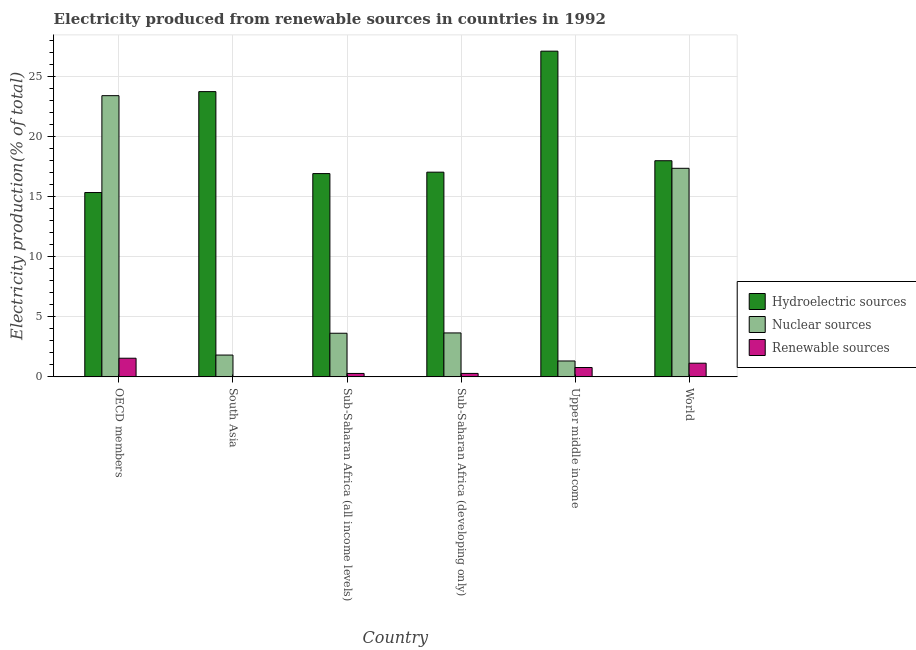How many groups of bars are there?
Your answer should be very brief. 6. How many bars are there on the 6th tick from the left?
Your answer should be very brief. 3. What is the percentage of electricity produced by renewable sources in Upper middle income?
Keep it short and to the point. 0.78. Across all countries, what is the maximum percentage of electricity produced by nuclear sources?
Provide a succinct answer. 23.41. Across all countries, what is the minimum percentage of electricity produced by nuclear sources?
Provide a succinct answer. 1.32. In which country was the percentage of electricity produced by renewable sources maximum?
Give a very brief answer. OECD members. In which country was the percentage of electricity produced by nuclear sources minimum?
Offer a very short reply. Upper middle income. What is the total percentage of electricity produced by hydroelectric sources in the graph?
Provide a short and direct response. 118.15. What is the difference between the percentage of electricity produced by renewable sources in OECD members and that in Sub-Saharan Africa (all income levels)?
Provide a short and direct response. 1.27. What is the difference between the percentage of electricity produced by hydroelectric sources in Sub-Saharan Africa (all income levels) and the percentage of electricity produced by renewable sources in World?
Provide a short and direct response. 15.78. What is the average percentage of electricity produced by renewable sources per country?
Ensure brevity in your answer.  0.68. What is the difference between the percentage of electricity produced by nuclear sources and percentage of electricity produced by hydroelectric sources in Sub-Saharan Africa (developing only)?
Provide a short and direct response. -13.38. In how many countries, is the percentage of electricity produced by hydroelectric sources greater than 23 %?
Your answer should be very brief. 2. What is the ratio of the percentage of electricity produced by renewable sources in South Asia to that in Sub-Saharan Africa (all income levels)?
Offer a very short reply. 0.08. What is the difference between the highest and the second highest percentage of electricity produced by renewable sources?
Offer a very short reply. 0.41. What is the difference between the highest and the lowest percentage of electricity produced by nuclear sources?
Provide a short and direct response. 22.08. In how many countries, is the percentage of electricity produced by renewable sources greater than the average percentage of electricity produced by renewable sources taken over all countries?
Provide a succinct answer. 3. What does the 1st bar from the left in OECD members represents?
Offer a very short reply. Hydroelectric sources. What does the 2nd bar from the right in South Asia represents?
Your answer should be compact. Nuclear sources. Is it the case that in every country, the sum of the percentage of electricity produced by hydroelectric sources and percentage of electricity produced by nuclear sources is greater than the percentage of electricity produced by renewable sources?
Your answer should be compact. Yes. Are all the bars in the graph horizontal?
Offer a terse response. No. What is the difference between two consecutive major ticks on the Y-axis?
Offer a very short reply. 5. Are the values on the major ticks of Y-axis written in scientific E-notation?
Keep it short and to the point. No. Does the graph contain grids?
Give a very brief answer. Yes. What is the title of the graph?
Your answer should be compact. Electricity produced from renewable sources in countries in 1992. What is the label or title of the X-axis?
Offer a very short reply. Country. What is the Electricity production(% of total) in Hydroelectric sources in OECD members?
Keep it short and to the point. 15.34. What is the Electricity production(% of total) of Nuclear sources in OECD members?
Provide a succinct answer. 23.41. What is the Electricity production(% of total) in Renewable sources in OECD members?
Offer a very short reply. 1.55. What is the Electricity production(% of total) in Hydroelectric sources in South Asia?
Give a very brief answer. 23.74. What is the Electricity production(% of total) of Nuclear sources in South Asia?
Offer a very short reply. 1.82. What is the Electricity production(% of total) in Renewable sources in South Asia?
Keep it short and to the point. 0.02. What is the Electricity production(% of total) in Hydroelectric sources in Sub-Saharan Africa (all income levels)?
Give a very brief answer. 16.92. What is the Electricity production(% of total) in Nuclear sources in Sub-Saharan Africa (all income levels)?
Provide a succinct answer. 3.63. What is the Electricity production(% of total) in Renewable sources in Sub-Saharan Africa (all income levels)?
Ensure brevity in your answer.  0.29. What is the Electricity production(% of total) of Hydroelectric sources in Sub-Saharan Africa (developing only)?
Your answer should be compact. 17.04. What is the Electricity production(% of total) in Nuclear sources in Sub-Saharan Africa (developing only)?
Keep it short and to the point. 3.66. What is the Electricity production(% of total) in Renewable sources in Sub-Saharan Africa (developing only)?
Provide a short and direct response. 0.29. What is the Electricity production(% of total) of Hydroelectric sources in Upper middle income?
Keep it short and to the point. 27.11. What is the Electricity production(% of total) of Nuclear sources in Upper middle income?
Your answer should be compact. 1.32. What is the Electricity production(% of total) of Renewable sources in Upper middle income?
Offer a very short reply. 0.78. What is the Electricity production(% of total) of Hydroelectric sources in World?
Give a very brief answer. 17.99. What is the Electricity production(% of total) of Nuclear sources in World?
Keep it short and to the point. 17.36. What is the Electricity production(% of total) in Renewable sources in World?
Your answer should be very brief. 1.14. Across all countries, what is the maximum Electricity production(% of total) of Hydroelectric sources?
Your answer should be compact. 27.11. Across all countries, what is the maximum Electricity production(% of total) in Nuclear sources?
Your answer should be compact. 23.41. Across all countries, what is the maximum Electricity production(% of total) in Renewable sources?
Offer a very short reply. 1.55. Across all countries, what is the minimum Electricity production(% of total) in Hydroelectric sources?
Offer a very short reply. 15.34. Across all countries, what is the minimum Electricity production(% of total) in Nuclear sources?
Make the answer very short. 1.32. Across all countries, what is the minimum Electricity production(% of total) of Renewable sources?
Offer a terse response. 0.02. What is the total Electricity production(% of total) of Hydroelectric sources in the graph?
Ensure brevity in your answer.  118.15. What is the total Electricity production(% of total) in Nuclear sources in the graph?
Make the answer very short. 51.19. What is the total Electricity production(% of total) in Renewable sources in the graph?
Give a very brief answer. 4.06. What is the difference between the Electricity production(% of total) in Hydroelectric sources in OECD members and that in South Asia?
Your answer should be compact. -8.4. What is the difference between the Electricity production(% of total) of Nuclear sources in OECD members and that in South Asia?
Offer a very short reply. 21.59. What is the difference between the Electricity production(% of total) of Renewable sources in OECD members and that in South Asia?
Keep it short and to the point. 1.53. What is the difference between the Electricity production(% of total) in Hydroelectric sources in OECD members and that in Sub-Saharan Africa (all income levels)?
Your answer should be very brief. -1.58. What is the difference between the Electricity production(% of total) in Nuclear sources in OECD members and that in Sub-Saharan Africa (all income levels)?
Your response must be concise. 19.77. What is the difference between the Electricity production(% of total) in Renewable sources in OECD members and that in Sub-Saharan Africa (all income levels)?
Provide a succinct answer. 1.27. What is the difference between the Electricity production(% of total) of Hydroelectric sources in OECD members and that in Sub-Saharan Africa (developing only)?
Offer a very short reply. -1.7. What is the difference between the Electricity production(% of total) in Nuclear sources in OECD members and that in Sub-Saharan Africa (developing only)?
Make the answer very short. 19.75. What is the difference between the Electricity production(% of total) of Renewable sources in OECD members and that in Sub-Saharan Africa (developing only)?
Make the answer very short. 1.26. What is the difference between the Electricity production(% of total) of Hydroelectric sources in OECD members and that in Upper middle income?
Your answer should be compact. -11.77. What is the difference between the Electricity production(% of total) of Nuclear sources in OECD members and that in Upper middle income?
Your answer should be very brief. 22.08. What is the difference between the Electricity production(% of total) of Renewable sources in OECD members and that in Upper middle income?
Your response must be concise. 0.77. What is the difference between the Electricity production(% of total) of Hydroelectric sources in OECD members and that in World?
Make the answer very short. -2.65. What is the difference between the Electricity production(% of total) in Nuclear sources in OECD members and that in World?
Offer a terse response. 6.05. What is the difference between the Electricity production(% of total) in Renewable sources in OECD members and that in World?
Keep it short and to the point. 0.41. What is the difference between the Electricity production(% of total) in Hydroelectric sources in South Asia and that in Sub-Saharan Africa (all income levels)?
Keep it short and to the point. 6.82. What is the difference between the Electricity production(% of total) of Nuclear sources in South Asia and that in Sub-Saharan Africa (all income levels)?
Provide a succinct answer. -1.82. What is the difference between the Electricity production(% of total) of Renewable sources in South Asia and that in Sub-Saharan Africa (all income levels)?
Your response must be concise. -0.26. What is the difference between the Electricity production(% of total) of Hydroelectric sources in South Asia and that in Sub-Saharan Africa (developing only)?
Your answer should be very brief. 6.7. What is the difference between the Electricity production(% of total) in Nuclear sources in South Asia and that in Sub-Saharan Africa (developing only)?
Your answer should be very brief. -1.84. What is the difference between the Electricity production(% of total) of Renewable sources in South Asia and that in Sub-Saharan Africa (developing only)?
Keep it short and to the point. -0.27. What is the difference between the Electricity production(% of total) of Hydroelectric sources in South Asia and that in Upper middle income?
Offer a very short reply. -3.37. What is the difference between the Electricity production(% of total) in Nuclear sources in South Asia and that in Upper middle income?
Offer a very short reply. 0.49. What is the difference between the Electricity production(% of total) of Renewable sources in South Asia and that in Upper middle income?
Offer a terse response. -0.76. What is the difference between the Electricity production(% of total) of Hydroelectric sources in South Asia and that in World?
Keep it short and to the point. 5.75. What is the difference between the Electricity production(% of total) of Nuclear sources in South Asia and that in World?
Offer a terse response. -15.54. What is the difference between the Electricity production(% of total) in Renewable sources in South Asia and that in World?
Your answer should be compact. -1.12. What is the difference between the Electricity production(% of total) in Hydroelectric sources in Sub-Saharan Africa (all income levels) and that in Sub-Saharan Africa (developing only)?
Keep it short and to the point. -0.12. What is the difference between the Electricity production(% of total) in Nuclear sources in Sub-Saharan Africa (all income levels) and that in Sub-Saharan Africa (developing only)?
Your response must be concise. -0.03. What is the difference between the Electricity production(% of total) of Renewable sources in Sub-Saharan Africa (all income levels) and that in Sub-Saharan Africa (developing only)?
Provide a succinct answer. -0. What is the difference between the Electricity production(% of total) of Hydroelectric sources in Sub-Saharan Africa (all income levels) and that in Upper middle income?
Keep it short and to the point. -10.19. What is the difference between the Electricity production(% of total) of Nuclear sources in Sub-Saharan Africa (all income levels) and that in Upper middle income?
Keep it short and to the point. 2.31. What is the difference between the Electricity production(% of total) of Renewable sources in Sub-Saharan Africa (all income levels) and that in Upper middle income?
Give a very brief answer. -0.49. What is the difference between the Electricity production(% of total) of Hydroelectric sources in Sub-Saharan Africa (all income levels) and that in World?
Provide a short and direct response. -1.07. What is the difference between the Electricity production(% of total) of Nuclear sources in Sub-Saharan Africa (all income levels) and that in World?
Offer a terse response. -13.73. What is the difference between the Electricity production(% of total) in Renewable sources in Sub-Saharan Africa (all income levels) and that in World?
Provide a succinct answer. -0.85. What is the difference between the Electricity production(% of total) of Hydroelectric sources in Sub-Saharan Africa (developing only) and that in Upper middle income?
Keep it short and to the point. -10.07. What is the difference between the Electricity production(% of total) of Nuclear sources in Sub-Saharan Africa (developing only) and that in Upper middle income?
Offer a very short reply. 2.33. What is the difference between the Electricity production(% of total) in Renewable sources in Sub-Saharan Africa (developing only) and that in Upper middle income?
Ensure brevity in your answer.  -0.49. What is the difference between the Electricity production(% of total) of Hydroelectric sources in Sub-Saharan Africa (developing only) and that in World?
Offer a terse response. -0.95. What is the difference between the Electricity production(% of total) in Nuclear sources in Sub-Saharan Africa (developing only) and that in World?
Provide a short and direct response. -13.7. What is the difference between the Electricity production(% of total) in Renewable sources in Sub-Saharan Africa (developing only) and that in World?
Your response must be concise. -0.85. What is the difference between the Electricity production(% of total) in Hydroelectric sources in Upper middle income and that in World?
Your answer should be very brief. 9.12. What is the difference between the Electricity production(% of total) of Nuclear sources in Upper middle income and that in World?
Provide a succinct answer. -16.04. What is the difference between the Electricity production(% of total) of Renewable sources in Upper middle income and that in World?
Your response must be concise. -0.36. What is the difference between the Electricity production(% of total) in Hydroelectric sources in OECD members and the Electricity production(% of total) in Nuclear sources in South Asia?
Your answer should be very brief. 13.53. What is the difference between the Electricity production(% of total) in Hydroelectric sources in OECD members and the Electricity production(% of total) in Renewable sources in South Asia?
Provide a short and direct response. 15.32. What is the difference between the Electricity production(% of total) in Nuclear sources in OECD members and the Electricity production(% of total) in Renewable sources in South Asia?
Ensure brevity in your answer.  23.38. What is the difference between the Electricity production(% of total) in Hydroelectric sources in OECD members and the Electricity production(% of total) in Nuclear sources in Sub-Saharan Africa (all income levels)?
Provide a short and direct response. 11.71. What is the difference between the Electricity production(% of total) of Hydroelectric sources in OECD members and the Electricity production(% of total) of Renewable sources in Sub-Saharan Africa (all income levels)?
Provide a succinct answer. 15.06. What is the difference between the Electricity production(% of total) in Nuclear sources in OECD members and the Electricity production(% of total) in Renewable sources in Sub-Saharan Africa (all income levels)?
Offer a terse response. 23.12. What is the difference between the Electricity production(% of total) in Hydroelectric sources in OECD members and the Electricity production(% of total) in Nuclear sources in Sub-Saharan Africa (developing only)?
Provide a short and direct response. 11.69. What is the difference between the Electricity production(% of total) in Hydroelectric sources in OECD members and the Electricity production(% of total) in Renewable sources in Sub-Saharan Africa (developing only)?
Give a very brief answer. 15.06. What is the difference between the Electricity production(% of total) in Nuclear sources in OECD members and the Electricity production(% of total) in Renewable sources in Sub-Saharan Africa (developing only)?
Keep it short and to the point. 23.12. What is the difference between the Electricity production(% of total) in Hydroelectric sources in OECD members and the Electricity production(% of total) in Nuclear sources in Upper middle income?
Give a very brief answer. 14.02. What is the difference between the Electricity production(% of total) in Hydroelectric sources in OECD members and the Electricity production(% of total) in Renewable sources in Upper middle income?
Your answer should be compact. 14.56. What is the difference between the Electricity production(% of total) in Nuclear sources in OECD members and the Electricity production(% of total) in Renewable sources in Upper middle income?
Make the answer very short. 22.63. What is the difference between the Electricity production(% of total) in Hydroelectric sources in OECD members and the Electricity production(% of total) in Nuclear sources in World?
Provide a succinct answer. -2.02. What is the difference between the Electricity production(% of total) in Hydroelectric sources in OECD members and the Electricity production(% of total) in Renewable sources in World?
Provide a short and direct response. 14.21. What is the difference between the Electricity production(% of total) of Nuclear sources in OECD members and the Electricity production(% of total) of Renewable sources in World?
Keep it short and to the point. 22.27. What is the difference between the Electricity production(% of total) in Hydroelectric sources in South Asia and the Electricity production(% of total) in Nuclear sources in Sub-Saharan Africa (all income levels)?
Your answer should be very brief. 20.11. What is the difference between the Electricity production(% of total) of Hydroelectric sources in South Asia and the Electricity production(% of total) of Renewable sources in Sub-Saharan Africa (all income levels)?
Your response must be concise. 23.46. What is the difference between the Electricity production(% of total) of Nuclear sources in South Asia and the Electricity production(% of total) of Renewable sources in Sub-Saharan Africa (all income levels)?
Offer a very short reply. 1.53. What is the difference between the Electricity production(% of total) of Hydroelectric sources in South Asia and the Electricity production(% of total) of Nuclear sources in Sub-Saharan Africa (developing only)?
Offer a terse response. 20.09. What is the difference between the Electricity production(% of total) of Hydroelectric sources in South Asia and the Electricity production(% of total) of Renewable sources in Sub-Saharan Africa (developing only)?
Give a very brief answer. 23.46. What is the difference between the Electricity production(% of total) in Nuclear sources in South Asia and the Electricity production(% of total) in Renewable sources in Sub-Saharan Africa (developing only)?
Give a very brief answer. 1.53. What is the difference between the Electricity production(% of total) of Hydroelectric sources in South Asia and the Electricity production(% of total) of Nuclear sources in Upper middle income?
Your response must be concise. 22.42. What is the difference between the Electricity production(% of total) in Hydroelectric sources in South Asia and the Electricity production(% of total) in Renewable sources in Upper middle income?
Offer a very short reply. 22.96. What is the difference between the Electricity production(% of total) in Nuclear sources in South Asia and the Electricity production(% of total) in Renewable sources in Upper middle income?
Offer a terse response. 1.04. What is the difference between the Electricity production(% of total) of Hydroelectric sources in South Asia and the Electricity production(% of total) of Nuclear sources in World?
Make the answer very short. 6.38. What is the difference between the Electricity production(% of total) of Hydroelectric sources in South Asia and the Electricity production(% of total) of Renewable sources in World?
Offer a very short reply. 22.61. What is the difference between the Electricity production(% of total) in Nuclear sources in South Asia and the Electricity production(% of total) in Renewable sources in World?
Your answer should be very brief. 0.68. What is the difference between the Electricity production(% of total) of Hydroelectric sources in Sub-Saharan Africa (all income levels) and the Electricity production(% of total) of Nuclear sources in Sub-Saharan Africa (developing only)?
Offer a terse response. 13.26. What is the difference between the Electricity production(% of total) of Hydroelectric sources in Sub-Saharan Africa (all income levels) and the Electricity production(% of total) of Renewable sources in Sub-Saharan Africa (developing only)?
Provide a short and direct response. 16.63. What is the difference between the Electricity production(% of total) of Nuclear sources in Sub-Saharan Africa (all income levels) and the Electricity production(% of total) of Renewable sources in Sub-Saharan Africa (developing only)?
Your response must be concise. 3.34. What is the difference between the Electricity production(% of total) in Hydroelectric sources in Sub-Saharan Africa (all income levels) and the Electricity production(% of total) in Nuclear sources in Upper middle income?
Keep it short and to the point. 15.6. What is the difference between the Electricity production(% of total) of Hydroelectric sources in Sub-Saharan Africa (all income levels) and the Electricity production(% of total) of Renewable sources in Upper middle income?
Your answer should be very brief. 16.14. What is the difference between the Electricity production(% of total) of Nuclear sources in Sub-Saharan Africa (all income levels) and the Electricity production(% of total) of Renewable sources in Upper middle income?
Provide a short and direct response. 2.85. What is the difference between the Electricity production(% of total) of Hydroelectric sources in Sub-Saharan Africa (all income levels) and the Electricity production(% of total) of Nuclear sources in World?
Offer a very short reply. -0.44. What is the difference between the Electricity production(% of total) of Hydroelectric sources in Sub-Saharan Africa (all income levels) and the Electricity production(% of total) of Renewable sources in World?
Your response must be concise. 15.78. What is the difference between the Electricity production(% of total) in Nuclear sources in Sub-Saharan Africa (all income levels) and the Electricity production(% of total) in Renewable sources in World?
Offer a terse response. 2.49. What is the difference between the Electricity production(% of total) in Hydroelectric sources in Sub-Saharan Africa (developing only) and the Electricity production(% of total) in Nuclear sources in Upper middle income?
Your response must be concise. 15.72. What is the difference between the Electricity production(% of total) in Hydroelectric sources in Sub-Saharan Africa (developing only) and the Electricity production(% of total) in Renewable sources in Upper middle income?
Keep it short and to the point. 16.26. What is the difference between the Electricity production(% of total) in Nuclear sources in Sub-Saharan Africa (developing only) and the Electricity production(% of total) in Renewable sources in Upper middle income?
Ensure brevity in your answer.  2.88. What is the difference between the Electricity production(% of total) in Hydroelectric sources in Sub-Saharan Africa (developing only) and the Electricity production(% of total) in Nuclear sources in World?
Your answer should be very brief. -0.32. What is the difference between the Electricity production(% of total) of Hydroelectric sources in Sub-Saharan Africa (developing only) and the Electricity production(% of total) of Renewable sources in World?
Offer a terse response. 15.9. What is the difference between the Electricity production(% of total) of Nuclear sources in Sub-Saharan Africa (developing only) and the Electricity production(% of total) of Renewable sources in World?
Keep it short and to the point. 2.52. What is the difference between the Electricity production(% of total) in Hydroelectric sources in Upper middle income and the Electricity production(% of total) in Nuclear sources in World?
Make the answer very short. 9.75. What is the difference between the Electricity production(% of total) of Hydroelectric sources in Upper middle income and the Electricity production(% of total) of Renewable sources in World?
Ensure brevity in your answer.  25.97. What is the difference between the Electricity production(% of total) in Nuclear sources in Upper middle income and the Electricity production(% of total) in Renewable sources in World?
Offer a terse response. 0.19. What is the average Electricity production(% of total) of Hydroelectric sources per country?
Provide a short and direct response. 19.69. What is the average Electricity production(% of total) of Nuclear sources per country?
Your answer should be compact. 8.53. What is the average Electricity production(% of total) in Renewable sources per country?
Your response must be concise. 0.68. What is the difference between the Electricity production(% of total) of Hydroelectric sources and Electricity production(% of total) of Nuclear sources in OECD members?
Offer a very short reply. -8.06. What is the difference between the Electricity production(% of total) in Hydroelectric sources and Electricity production(% of total) in Renewable sources in OECD members?
Ensure brevity in your answer.  13.79. What is the difference between the Electricity production(% of total) in Nuclear sources and Electricity production(% of total) in Renewable sources in OECD members?
Your answer should be very brief. 21.85. What is the difference between the Electricity production(% of total) in Hydroelectric sources and Electricity production(% of total) in Nuclear sources in South Asia?
Offer a terse response. 21.93. What is the difference between the Electricity production(% of total) of Hydroelectric sources and Electricity production(% of total) of Renewable sources in South Asia?
Make the answer very short. 23.72. What is the difference between the Electricity production(% of total) in Nuclear sources and Electricity production(% of total) in Renewable sources in South Asia?
Your answer should be compact. 1.79. What is the difference between the Electricity production(% of total) in Hydroelectric sources and Electricity production(% of total) in Nuclear sources in Sub-Saharan Africa (all income levels)?
Keep it short and to the point. 13.29. What is the difference between the Electricity production(% of total) of Hydroelectric sources and Electricity production(% of total) of Renewable sources in Sub-Saharan Africa (all income levels)?
Provide a succinct answer. 16.64. What is the difference between the Electricity production(% of total) of Nuclear sources and Electricity production(% of total) of Renewable sources in Sub-Saharan Africa (all income levels)?
Your response must be concise. 3.35. What is the difference between the Electricity production(% of total) of Hydroelectric sources and Electricity production(% of total) of Nuclear sources in Sub-Saharan Africa (developing only)?
Your answer should be compact. 13.38. What is the difference between the Electricity production(% of total) of Hydroelectric sources and Electricity production(% of total) of Renewable sources in Sub-Saharan Africa (developing only)?
Ensure brevity in your answer.  16.75. What is the difference between the Electricity production(% of total) of Nuclear sources and Electricity production(% of total) of Renewable sources in Sub-Saharan Africa (developing only)?
Keep it short and to the point. 3.37. What is the difference between the Electricity production(% of total) in Hydroelectric sources and Electricity production(% of total) in Nuclear sources in Upper middle income?
Your answer should be compact. 25.79. What is the difference between the Electricity production(% of total) of Hydroelectric sources and Electricity production(% of total) of Renewable sources in Upper middle income?
Offer a terse response. 26.33. What is the difference between the Electricity production(% of total) of Nuclear sources and Electricity production(% of total) of Renewable sources in Upper middle income?
Offer a very short reply. 0.54. What is the difference between the Electricity production(% of total) of Hydroelectric sources and Electricity production(% of total) of Nuclear sources in World?
Keep it short and to the point. 0.63. What is the difference between the Electricity production(% of total) of Hydroelectric sources and Electricity production(% of total) of Renewable sources in World?
Ensure brevity in your answer.  16.85. What is the difference between the Electricity production(% of total) of Nuclear sources and Electricity production(% of total) of Renewable sources in World?
Offer a terse response. 16.22. What is the ratio of the Electricity production(% of total) in Hydroelectric sources in OECD members to that in South Asia?
Give a very brief answer. 0.65. What is the ratio of the Electricity production(% of total) in Nuclear sources in OECD members to that in South Asia?
Ensure brevity in your answer.  12.89. What is the ratio of the Electricity production(% of total) in Renewable sources in OECD members to that in South Asia?
Give a very brief answer. 70.94. What is the ratio of the Electricity production(% of total) in Hydroelectric sources in OECD members to that in Sub-Saharan Africa (all income levels)?
Keep it short and to the point. 0.91. What is the ratio of the Electricity production(% of total) of Nuclear sources in OECD members to that in Sub-Saharan Africa (all income levels)?
Make the answer very short. 6.44. What is the ratio of the Electricity production(% of total) of Renewable sources in OECD members to that in Sub-Saharan Africa (all income levels)?
Keep it short and to the point. 5.44. What is the ratio of the Electricity production(% of total) of Hydroelectric sources in OECD members to that in Sub-Saharan Africa (developing only)?
Provide a short and direct response. 0.9. What is the ratio of the Electricity production(% of total) of Nuclear sources in OECD members to that in Sub-Saharan Africa (developing only)?
Your answer should be very brief. 6.4. What is the ratio of the Electricity production(% of total) of Renewable sources in OECD members to that in Sub-Saharan Africa (developing only)?
Your answer should be very brief. 5.4. What is the ratio of the Electricity production(% of total) in Hydroelectric sources in OECD members to that in Upper middle income?
Your answer should be very brief. 0.57. What is the ratio of the Electricity production(% of total) in Nuclear sources in OECD members to that in Upper middle income?
Your answer should be very brief. 17.69. What is the ratio of the Electricity production(% of total) of Renewable sources in OECD members to that in Upper middle income?
Make the answer very short. 1.99. What is the ratio of the Electricity production(% of total) of Hydroelectric sources in OECD members to that in World?
Your answer should be compact. 0.85. What is the ratio of the Electricity production(% of total) in Nuclear sources in OECD members to that in World?
Your answer should be very brief. 1.35. What is the ratio of the Electricity production(% of total) of Renewable sources in OECD members to that in World?
Offer a terse response. 1.36. What is the ratio of the Electricity production(% of total) of Hydroelectric sources in South Asia to that in Sub-Saharan Africa (all income levels)?
Your answer should be very brief. 1.4. What is the ratio of the Electricity production(% of total) of Nuclear sources in South Asia to that in Sub-Saharan Africa (all income levels)?
Your answer should be compact. 0.5. What is the ratio of the Electricity production(% of total) in Renewable sources in South Asia to that in Sub-Saharan Africa (all income levels)?
Provide a short and direct response. 0.08. What is the ratio of the Electricity production(% of total) in Hydroelectric sources in South Asia to that in Sub-Saharan Africa (developing only)?
Offer a very short reply. 1.39. What is the ratio of the Electricity production(% of total) of Nuclear sources in South Asia to that in Sub-Saharan Africa (developing only)?
Offer a very short reply. 0.5. What is the ratio of the Electricity production(% of total) of Renewable sources in South Asia to that in Sub-Saharan Africa (developing only)?
Your answer should be compact. 0.08. What is the ratio of the Electricity production(% of total) of Hydroelectric sources in South Asia to that in Upper middle income?
Provide a short and direct response. 0.88. What is the ratio of the Electricity production(% of total) in Nuclear sources in South Asia to that in Upper middle income?
Make the answer very short. 1.37. What is the ratio of the Electricity production(% of total) of Renewable sources in South Asia to that in Upper middle income?
Your answer should be compact. 0.03. What is the ratio of the Electricity production(% of total) in Hydroelectric sources in South Asia to that in World?
Make the answer very short. 1.32. What is the ratio of the Electricity production(% of total) in Nuclear sources in South Asia to that in World?
Offer a very short reply. 0.1. What is the ratio of the Electricity production(% of total) of Renewable sources in South Asia to that in World?
Your response must be concise. 0.02. What is the ratio of the Electricity production(% of total) of Hydroelectric sources in Sub-Saharan Africa (all income levels) to that in Upper middle income?
Offer a very short reply. 0.62. What is the ratio of the Electricity production(% of total) of Nuclear sources in Sub-Saharan Africa (all income levels) to that in Upper middle income?
Your answer should be compact. 2.75. What is the ratio of the Electricity production(% of total) of Renewable sources in Sub-Saharan Africa (all income levels) to that in Upper middle income?
Ensure brevity in your answer.  0.37. What is the ratio of the Electricity production(% of total) of Hydroelectric sources in Sub-Saharan Africa (all income levels) to that in World?
Your response must be concise. 0.94. What is the ratio of the Electricity production(% of total) of Nuclear sources in Sub-Saharan Africa (all income levels) to that in World?
Offer a terse response. 0.21. What is the ratio of the Electricity production(% of total) in Renewable sources in Sub-Saharan Africa (all income levels) to that in World?
Ensure brevity in your answer.  0.25. What is the ratio of the Electricity production(% of total) of Hydroelectric sources in Sub-Saharan Africa (developing only) to that in Upper middle income?
Your response must be concise. 0.63. What is the ratio of the Electricity production(% of total) in Nuclear sources in Sub-Saharan Africa (developing only) to that in Upper middle income?
Give a very brief answer. 2.76. What is the ratio of the Electricity production(% of total) of Renewable sources in Sub-Saharan Africa (developing only) to that in Upper middle income?
Your answer should be very brief. 0.37. What is the ratio of the Electricity production(% of total) of Hydroelectric sources in Sub-Saharan Africa (developing only) to that in World?
Ensure brevity in your answer.  0.95. What is the ratio of the Electricity production(% of total) in Nuclear sources in Sub-Saharan Africa (developing only) to that in World?
Your answer should be very brief. 0.21. What is the ratio of the Electricity production(% of total) of Renewable sources in Sub-Saharan Africa (developing only) to that in World?
Offer a terse response. 0.25. What is the ratio of the Electricity production(% of total) of Hydroelectric sources in Upper middle income to that in World?
Provide a short and direct response. 1.51. What is the ratio of the Electricity production(% of total) in Nuclear sources in Upper middle income to that in World?
Make the answer very short. 0.08. What is the ratio of the Electricity production(% of total) in Renewable sources in Upper middle income to that in World?
Your answer should be compact. 0.69. What is the difference between the highest and the second highest Electricity production(% of total) in Hydroelectric sources?
Your answer should be very brief. 3.37. What is the difference between the highest and the second highest Electricity production(% of total) in Nuclear sources?
Provide a short and direct response. 6.05. What is the difference between the highest and the second highest Electricity production(% of total) of Renewable sources?
Offer a terse response. 0.41. What is the difference between the highest and the lowest Electricity production(% of total) in Hydroelectric sources?
Your response must be concise. 11.77. What is the difference between the highest and the lowest Electricity production(% of total) of Nuclear sources?
Keep it short and to the point. 22.08. What is the difference between the highest and the lowest Electricity production(% of total) of Renewable sources?
Your answer should be very brief. 1.53. 